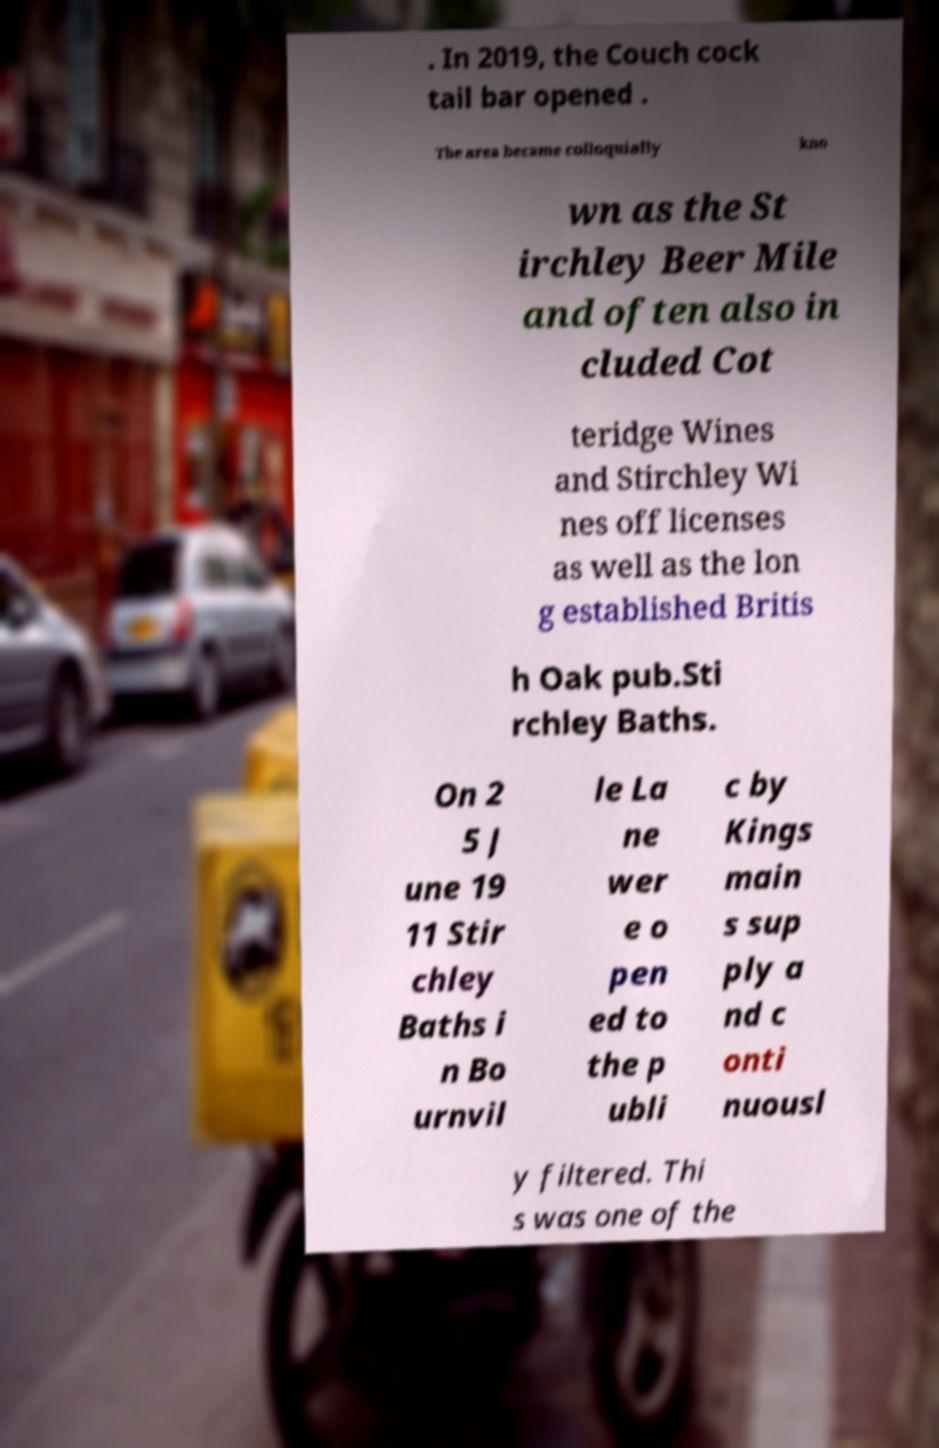Could you extract and type out the text from this image? . In 2019, the Couch cock tail bar opened . The area became colloquially kno wn as the St irchley Beer Mile and often also in cluded Cot teridge Wines and Stirchley Wi nes off licenses as well as the lon g established Britis h Oak pub.Sti rchley Baths. On 2 5 J une 19 11 Stir chley Baths i n Bo urnvil le La ne wer e o pen ed to the p ubli c by Kings main s sup ply a nd c onti nuousl y filtered. Thi s was one of the 